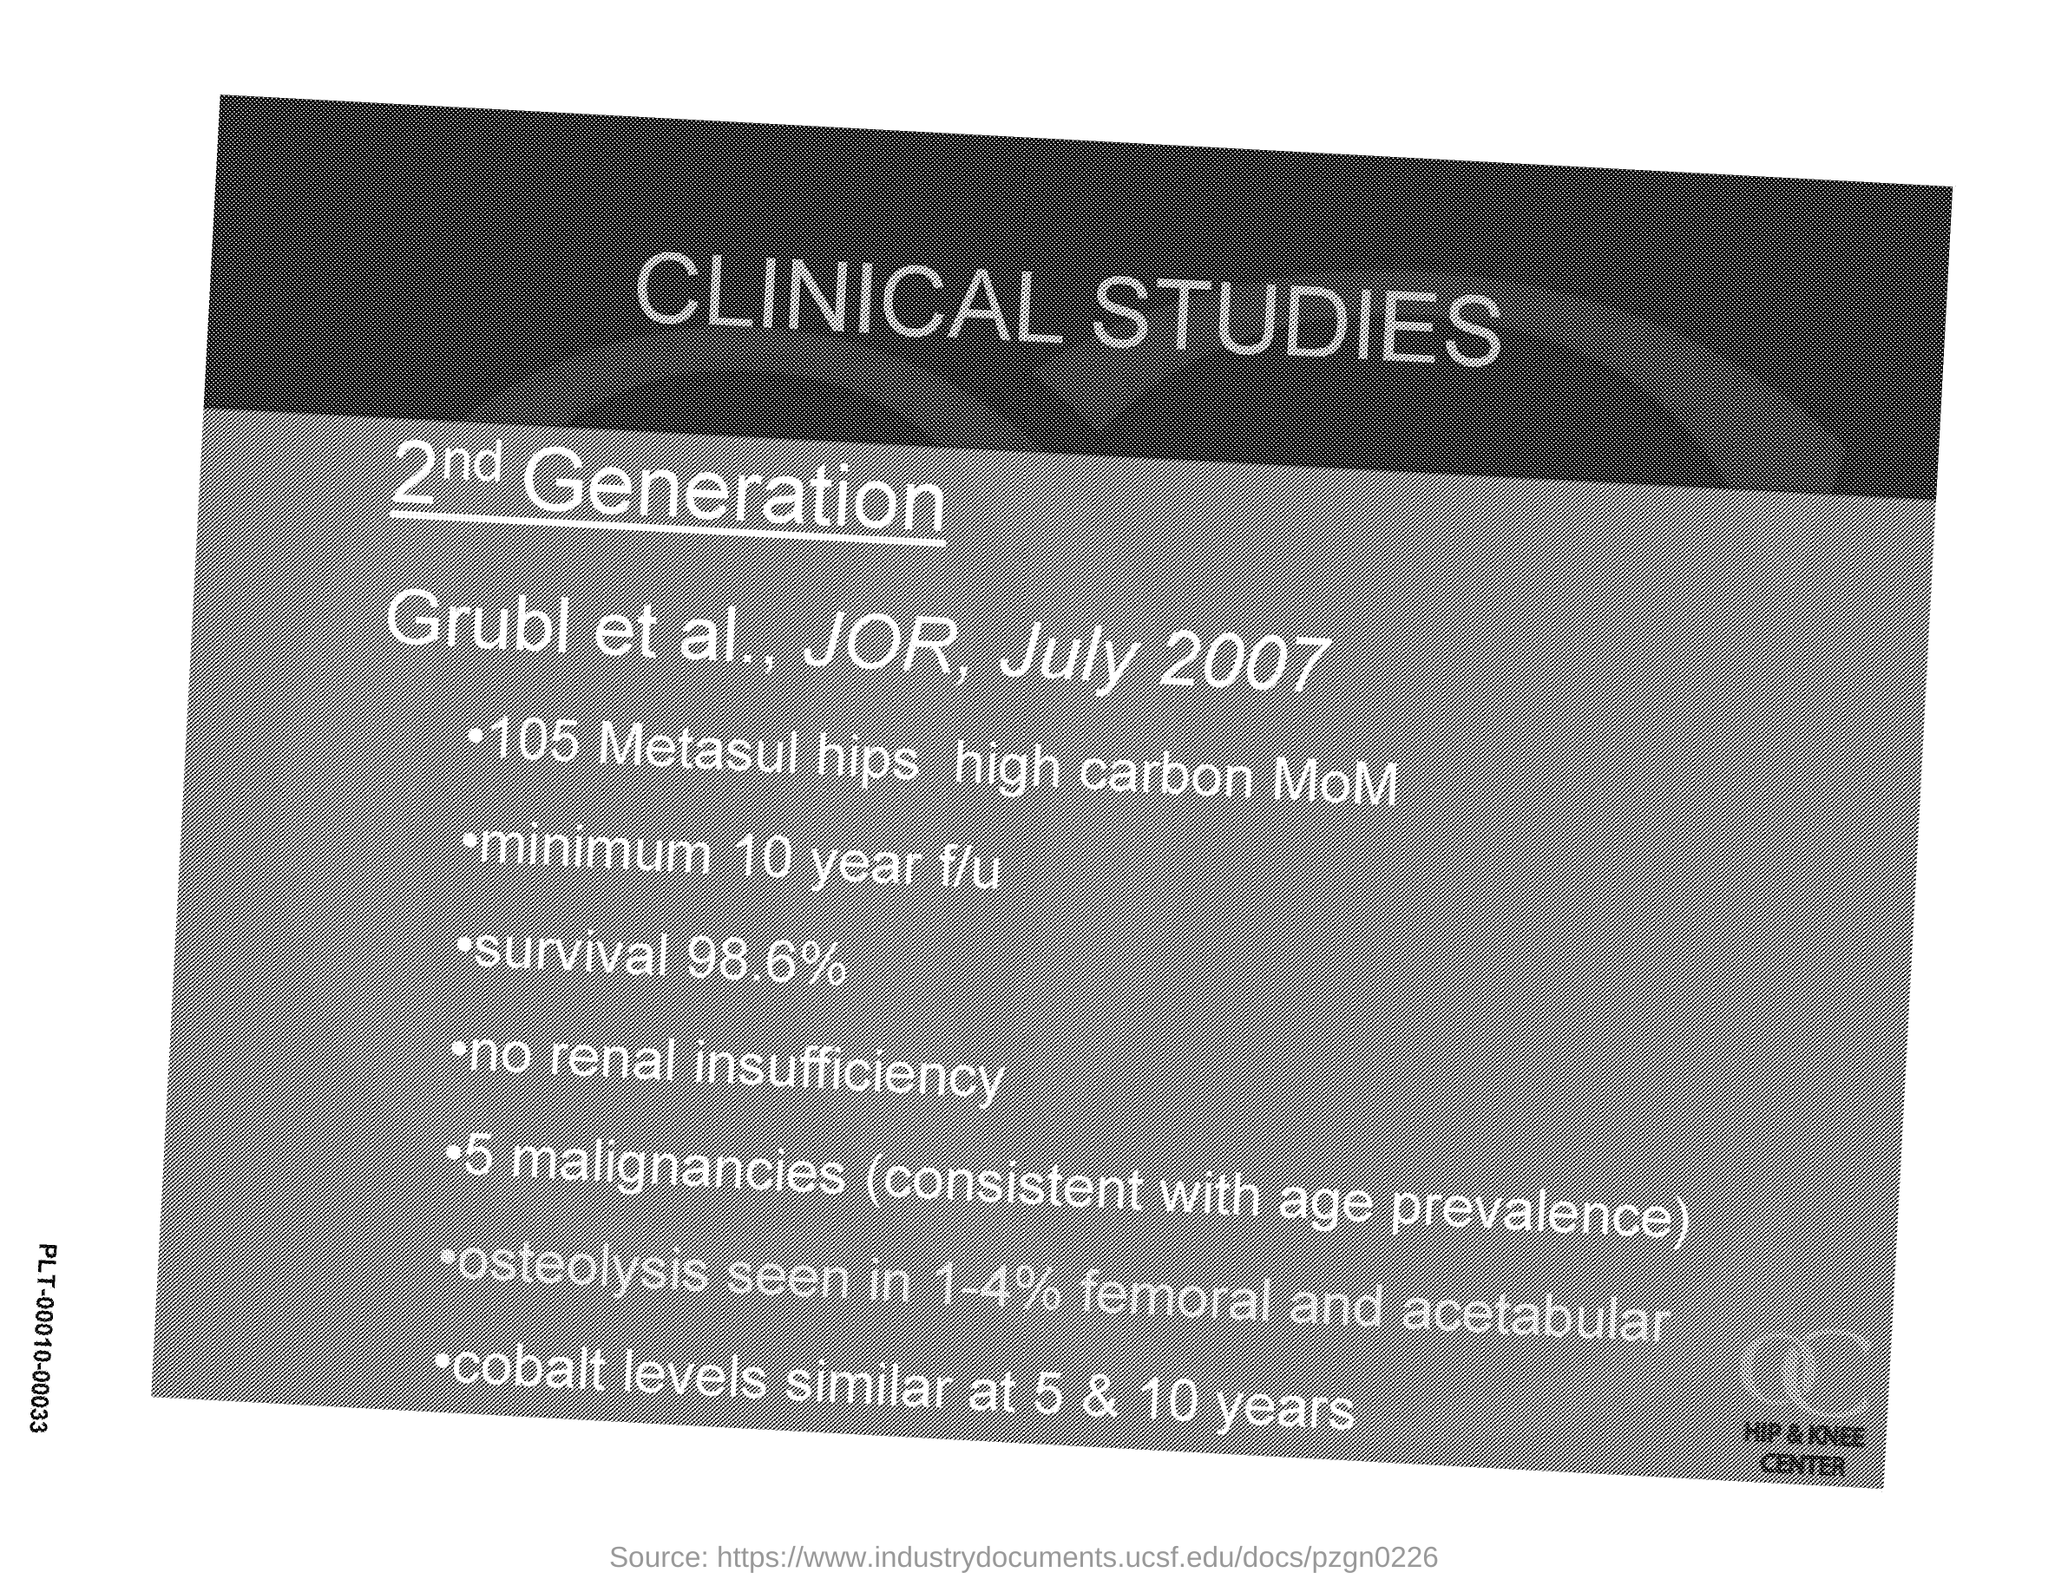Highlight a few significant elements in this photo. The date indicated on the document is July 2007. The title of the document is 'Clinical Studies.' 